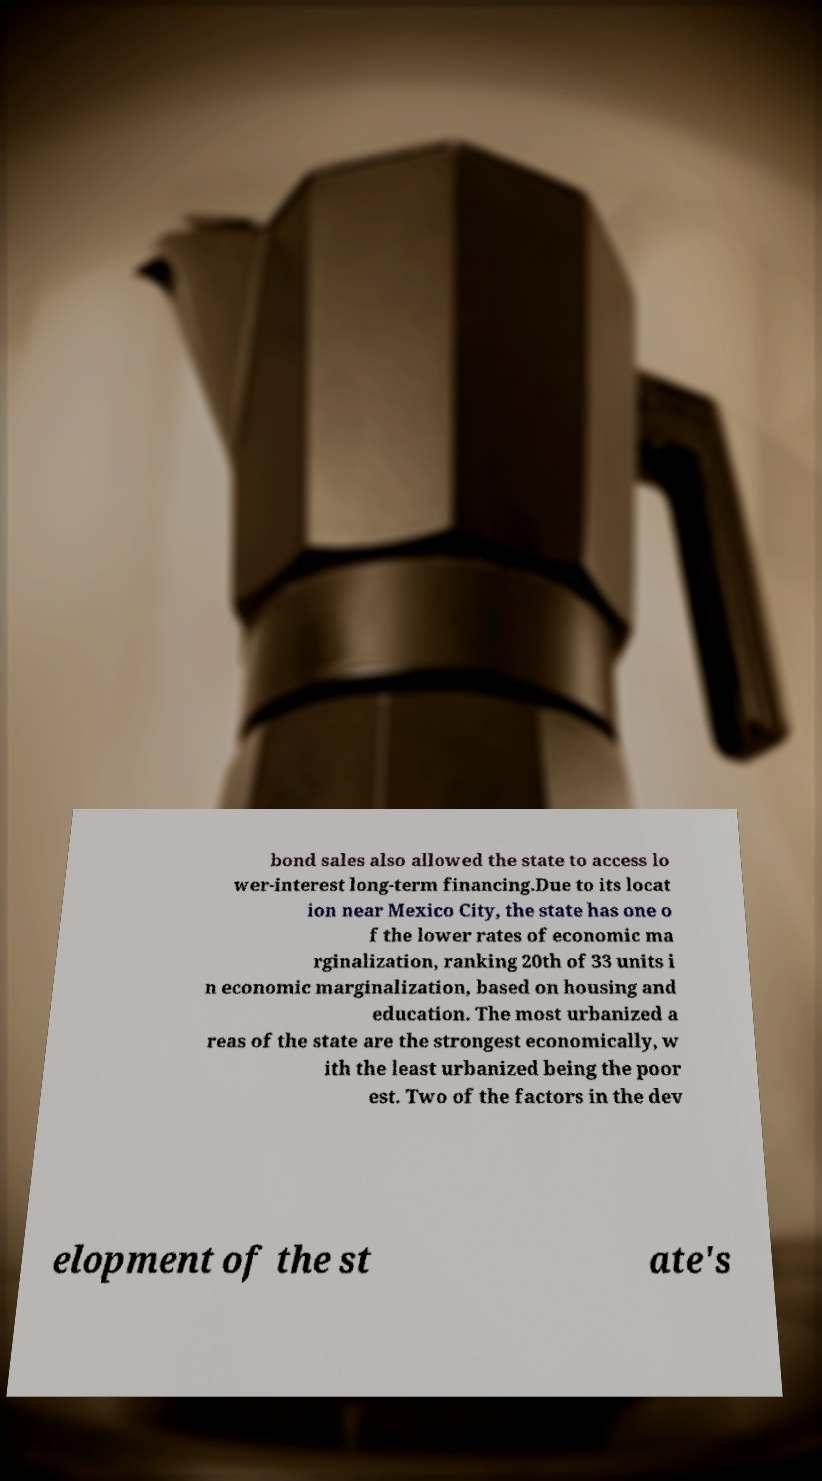Could you assist in decoding the text presented in this image and type it out clearly? bond sales also allowed the state to access lo wer-interest long-term financing.Due to its locat ion near Mexico City, the state has one o f the lower rates of economic ma rginalization, ranking 20th of 33 units i n economic marginalization, based on housing and education. The most urbanized a reas of the state are the strongest economically, w ith the least urbanized being the poor est. Two of the factors in the dev elopment of the st ate's 